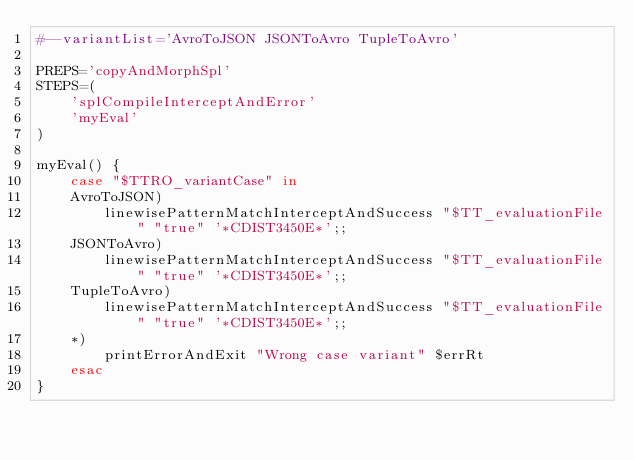Convert code to text. <code><loc_0><loc_0><loc_500><loc_500><_Bash_>#--variantList='AvroToJSON JSONToAvro TupleToAvro'

PREPS='copyAndMorphSpl'
STEPS=(
	'splCompileInterceptAndError'
	'myEval'
)

myEval() {
	case "$TTRO_variantCase" in
	AvroToJSON)
		linewisePatternMatchInterceptAndSuccess "$TT_evaluationFile" "true" '*CDIST3450E*';;
	JSONToAvro)
		linewisePatternMatchInterceptAndSuccess "$TT_evaluationFile" "true" '*CDIST3450E*';;
	TupleToAvro)
		linewisePatternMatchInterceptAndSuccess "$TT_evaluationFile" "true" '*CDIST3450E*';;
	*)
		printErrorAndExit "Wrong case variant" $errRt
	esac
}
</code> 